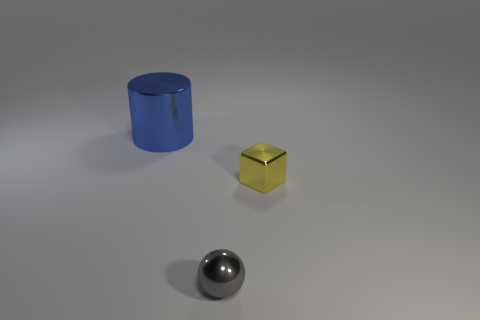There is a metallic object left of the gray sphere; is its size the same as the metallic object on the right side of the small gray shiny ball?
Offer a terse response. No. Is there anything else that has the same material as the gray thing?
Provide a short and direct response. Yes. How many big objects are gray objects or shiny things?
Provide a succinct answer. 1. How many things are objects that are right of the blue cylinder or big metallic cylinders?
Your answer should be compact. 3. Do the shiny cylinder and the block have the same color?
Your answer should be very brief. No. How many other objects are there of the same shape as the large blue object?
Offer a very short reply. 0. What number of yellow objects are either tiny metallic cubes or big cylinders?
Your answer should be very brief. 1. What is the color of the cube that is the same material as the big cylinder?
Provide a short and direct response. Yellow. Do the tiny object behind the gray shiny ball and the object in front of the small yellow metallic object have the same material?
Make the answer very short. Yes. What is the material of the object that is behind the small yellow thing?
Ensure brevity in your answer.  Metal. 